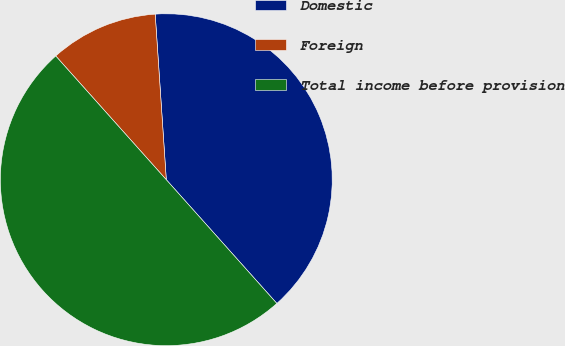<chart> <loc_0><loc_0><loc_500><loc_500><pie_chart><fcel>Domestic<fcel>Foreign<fcel>Total income before provision<nl><fcel>39.46%<fcel>10.54%<fcel>50.0%<nl></chart> 